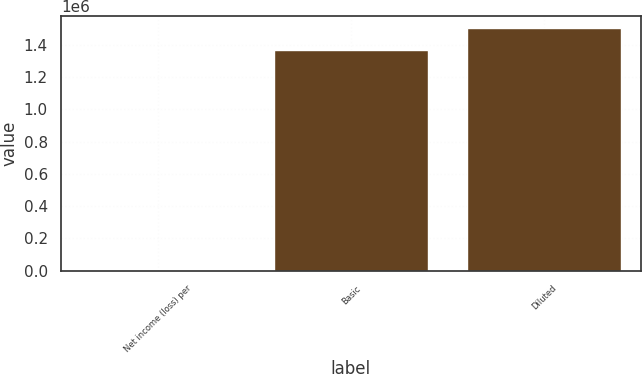<chart> <loc_0><loc_0><loc_500><loc_500><bar_chart><fcel>Net income (loss) per<fcel>Basic<fcel>Diluted<nl><fcel>0.27<fcel>1.36692e+06<fcel>1.50534e+06<nl></chart> 